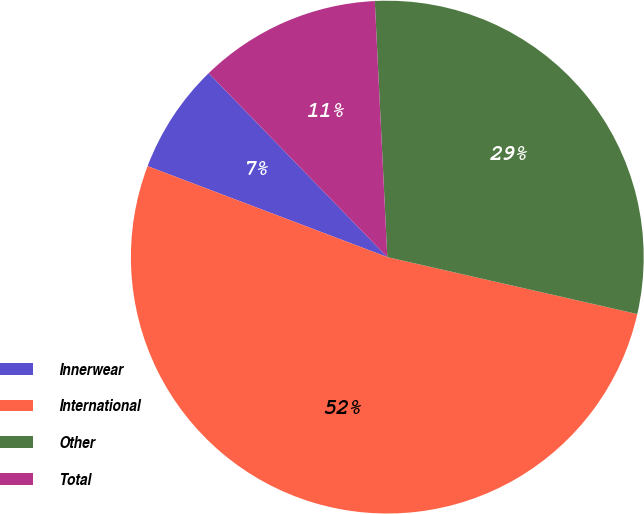<chart> <loc_0><loc_0><loc_500><loc_500><pie_chart><fcel>Innerwear<fcel>International<fcel>Other<fcel>Total<nl><fcel>6.96%<fcel>52.21%<fcel>29.34%<fcel>11.49%<nl></chart> 